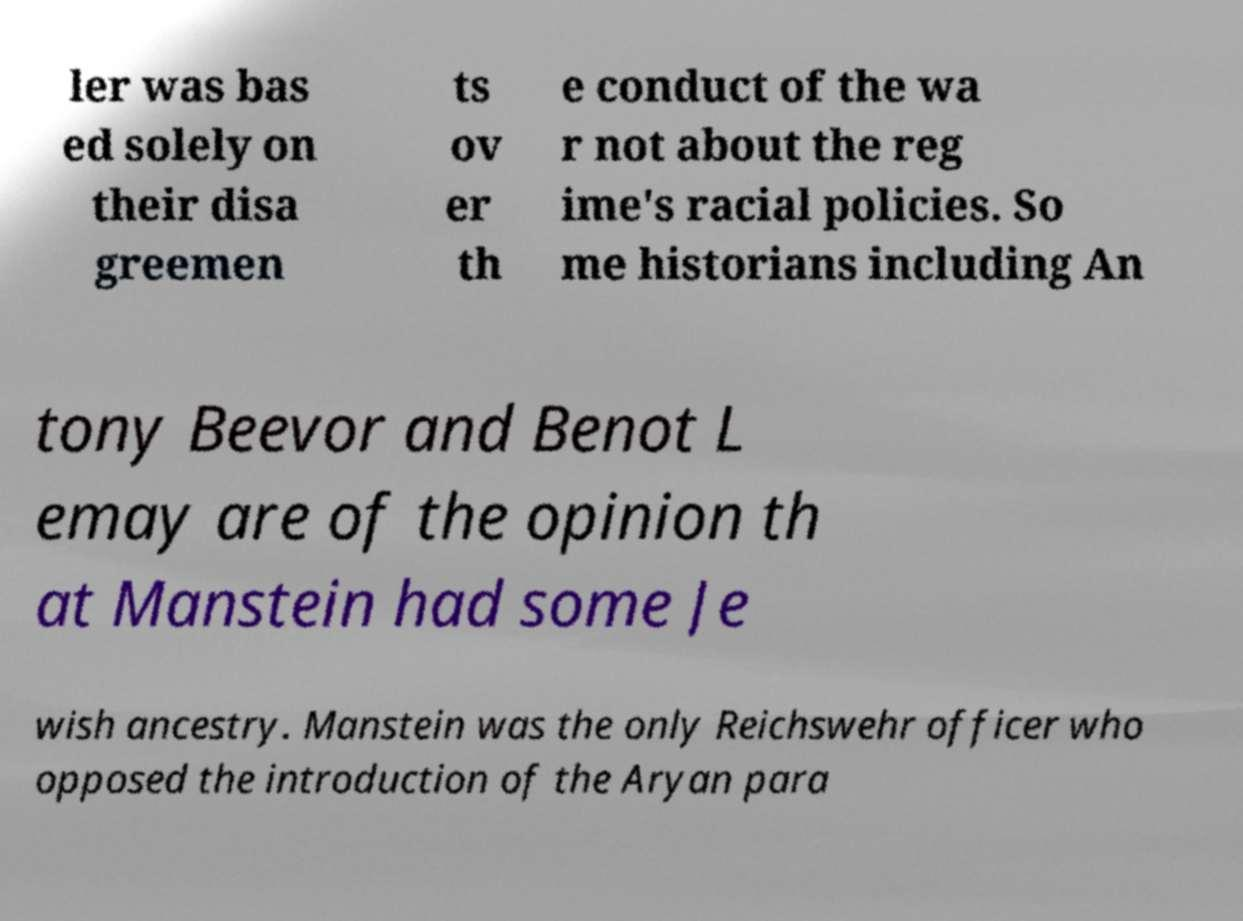I need the written content from this picture converted into text. Can you do that? ler was bas ed solely on their disa greemen ts ov er th e conduct of the wa r not about the reg ime's racial policies. So me historians including An tony Beevor and Benot L emay are of the opinion th at Manstein had some Je wish ancestry. Manstein was the only Reichswehr officer who opposed the introduction of the Aryan para 